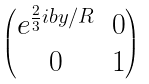<formula> <loc_0><loc_0><loc_500><loc_500>\begin{pmatrix} e ^ { \frac { 2 } { 3 } i b y / R } & 0 \\ 0 & 1 \end{pmatrix}</formula> 